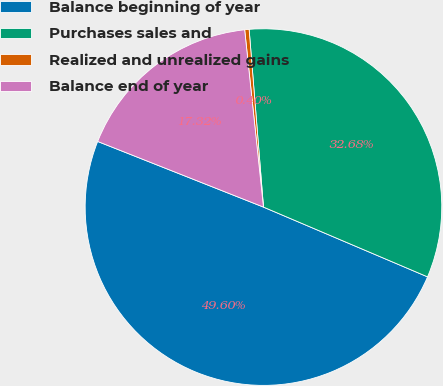Convert chart to OTSL. <chart><loc_0><loc_0><loc_500><loc_500><pie_chart><fcel>Balance beginning of year<fcel>Purchases sales and<fcel>Realized and unrealized gains<fcel>Balance end of year<nl><fcel>49.6%<fcel>32.68%<fcel>0.4%<fcel>17.32%<nl></chart> 